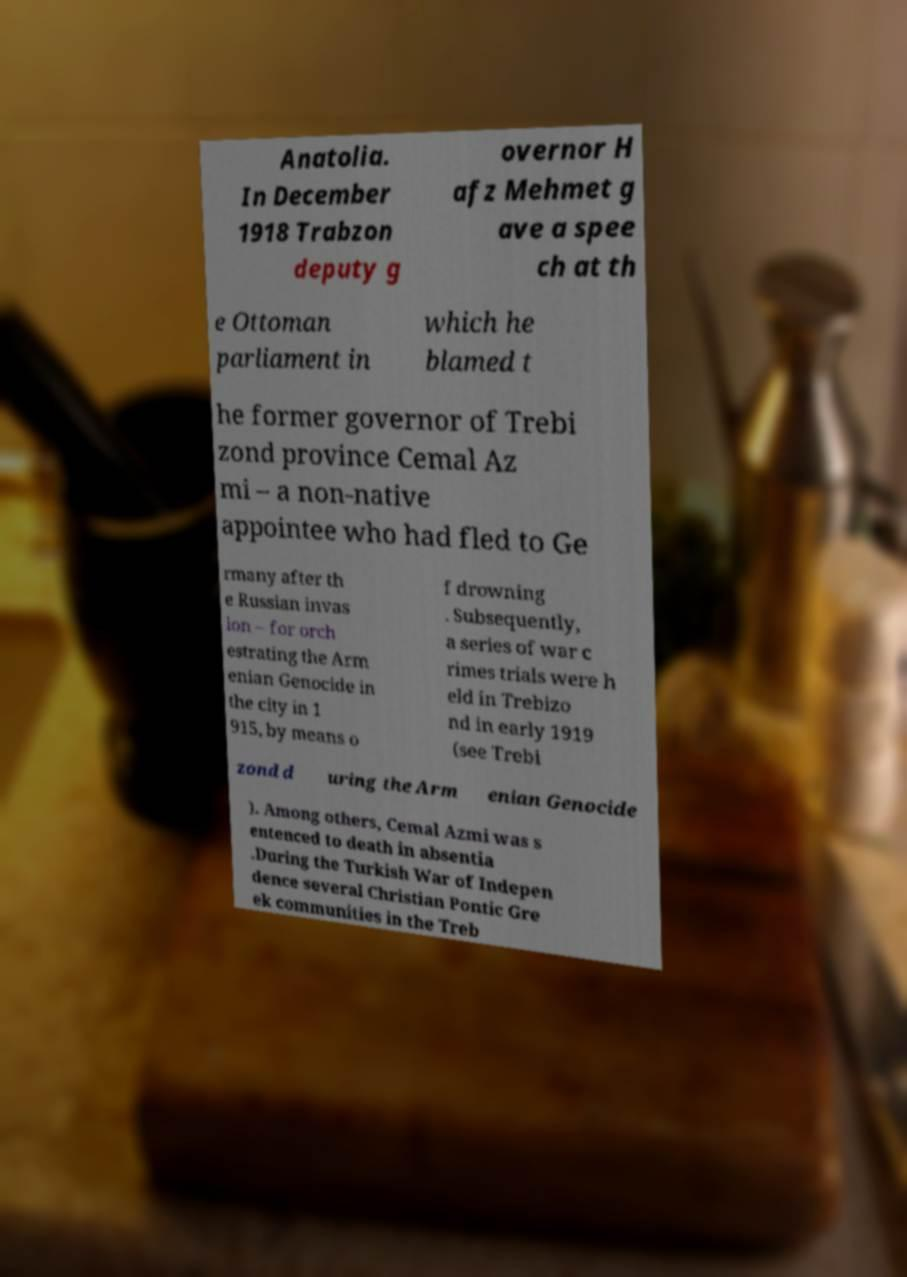I need the written content from this picture converted into text. Can you do that? Anatolia. In December 1918 Trabzon deputy g overnor H afz Mehmet g ave a spee ch at th e Ottoman parliament in which he blamed t he former governor of Trebi zond province Cemal Az mi – a non-native appointee who had fled to Ge rmany after th e Russian invas ion – for orch estrating the Arm enian Genocide in the city in 1 915, by means o f drowning . Subsequently, a series of war c rimes trials were h eld in Trebizo nd in early 1919 (see Trebi zond d uring the Arm enian Genocide ). Among others, Cemal Azmi was s entenced to death in absentia .During the Turkish War of Indepen dence several Christian Pontic Gre ek communities in the Treb 